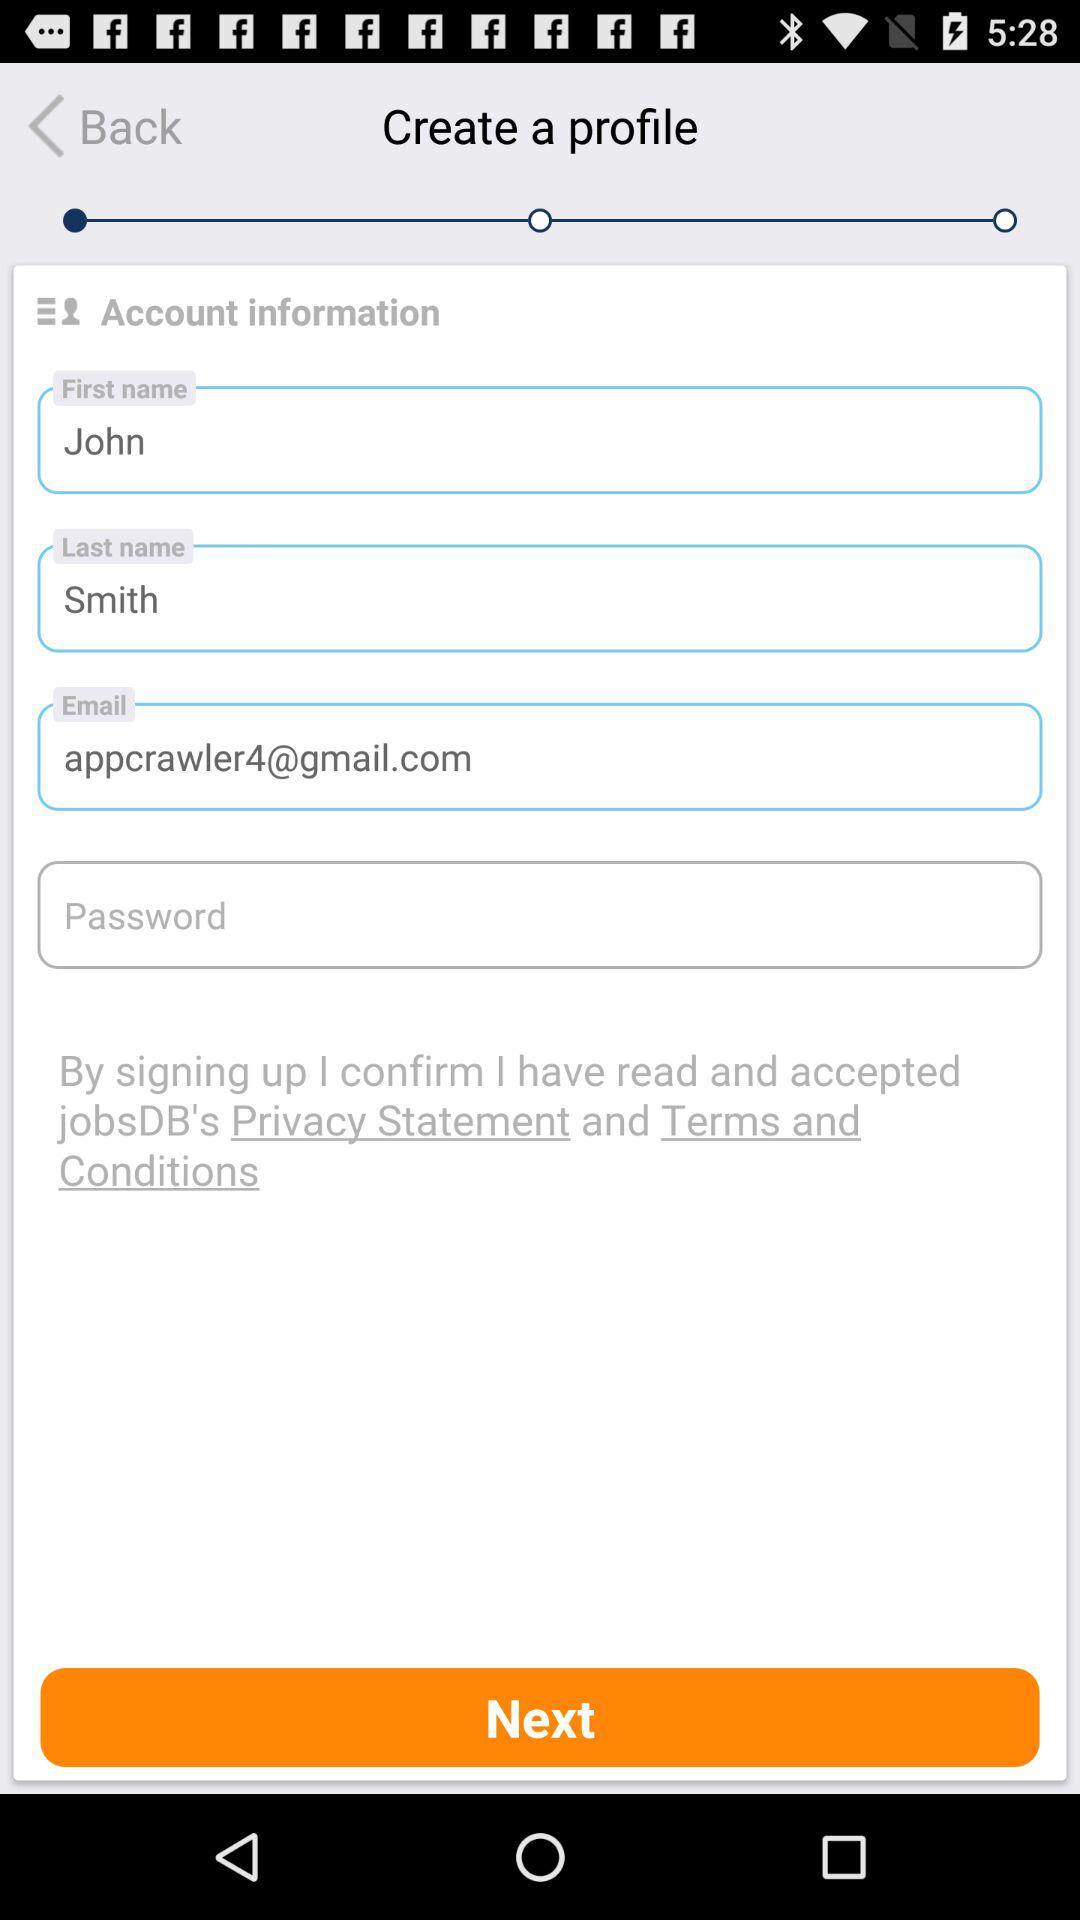What is the name? The name is John Smith. 